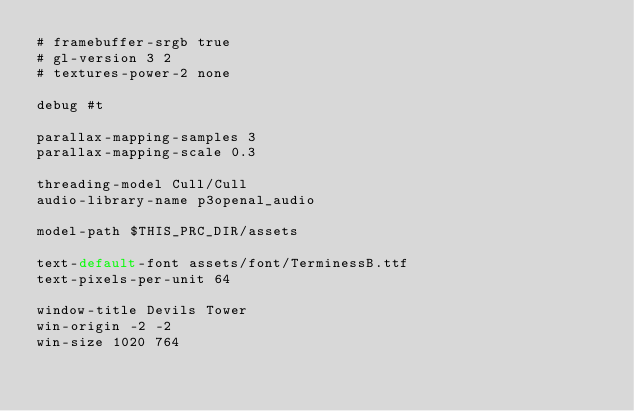<code> <loc_0><loc_0><loc_500><loc_500><_SQL_># framebuffer-srgb true
# gl-version 3 2
# textures-power-2 none

debug #t

parallax-mapping-samples 3
parallax-mapping-scale 0.3

threading-model Cull/Cull
audio-library-name p3openal_audio

model-path $THIS_PRC_DIR/assets

text-default-font assets/font/TerminessB.ttf
text-pixels-per-unit 64

window-title Devils Tower
win-origin -2 -2
win-size 1020 764</code> 